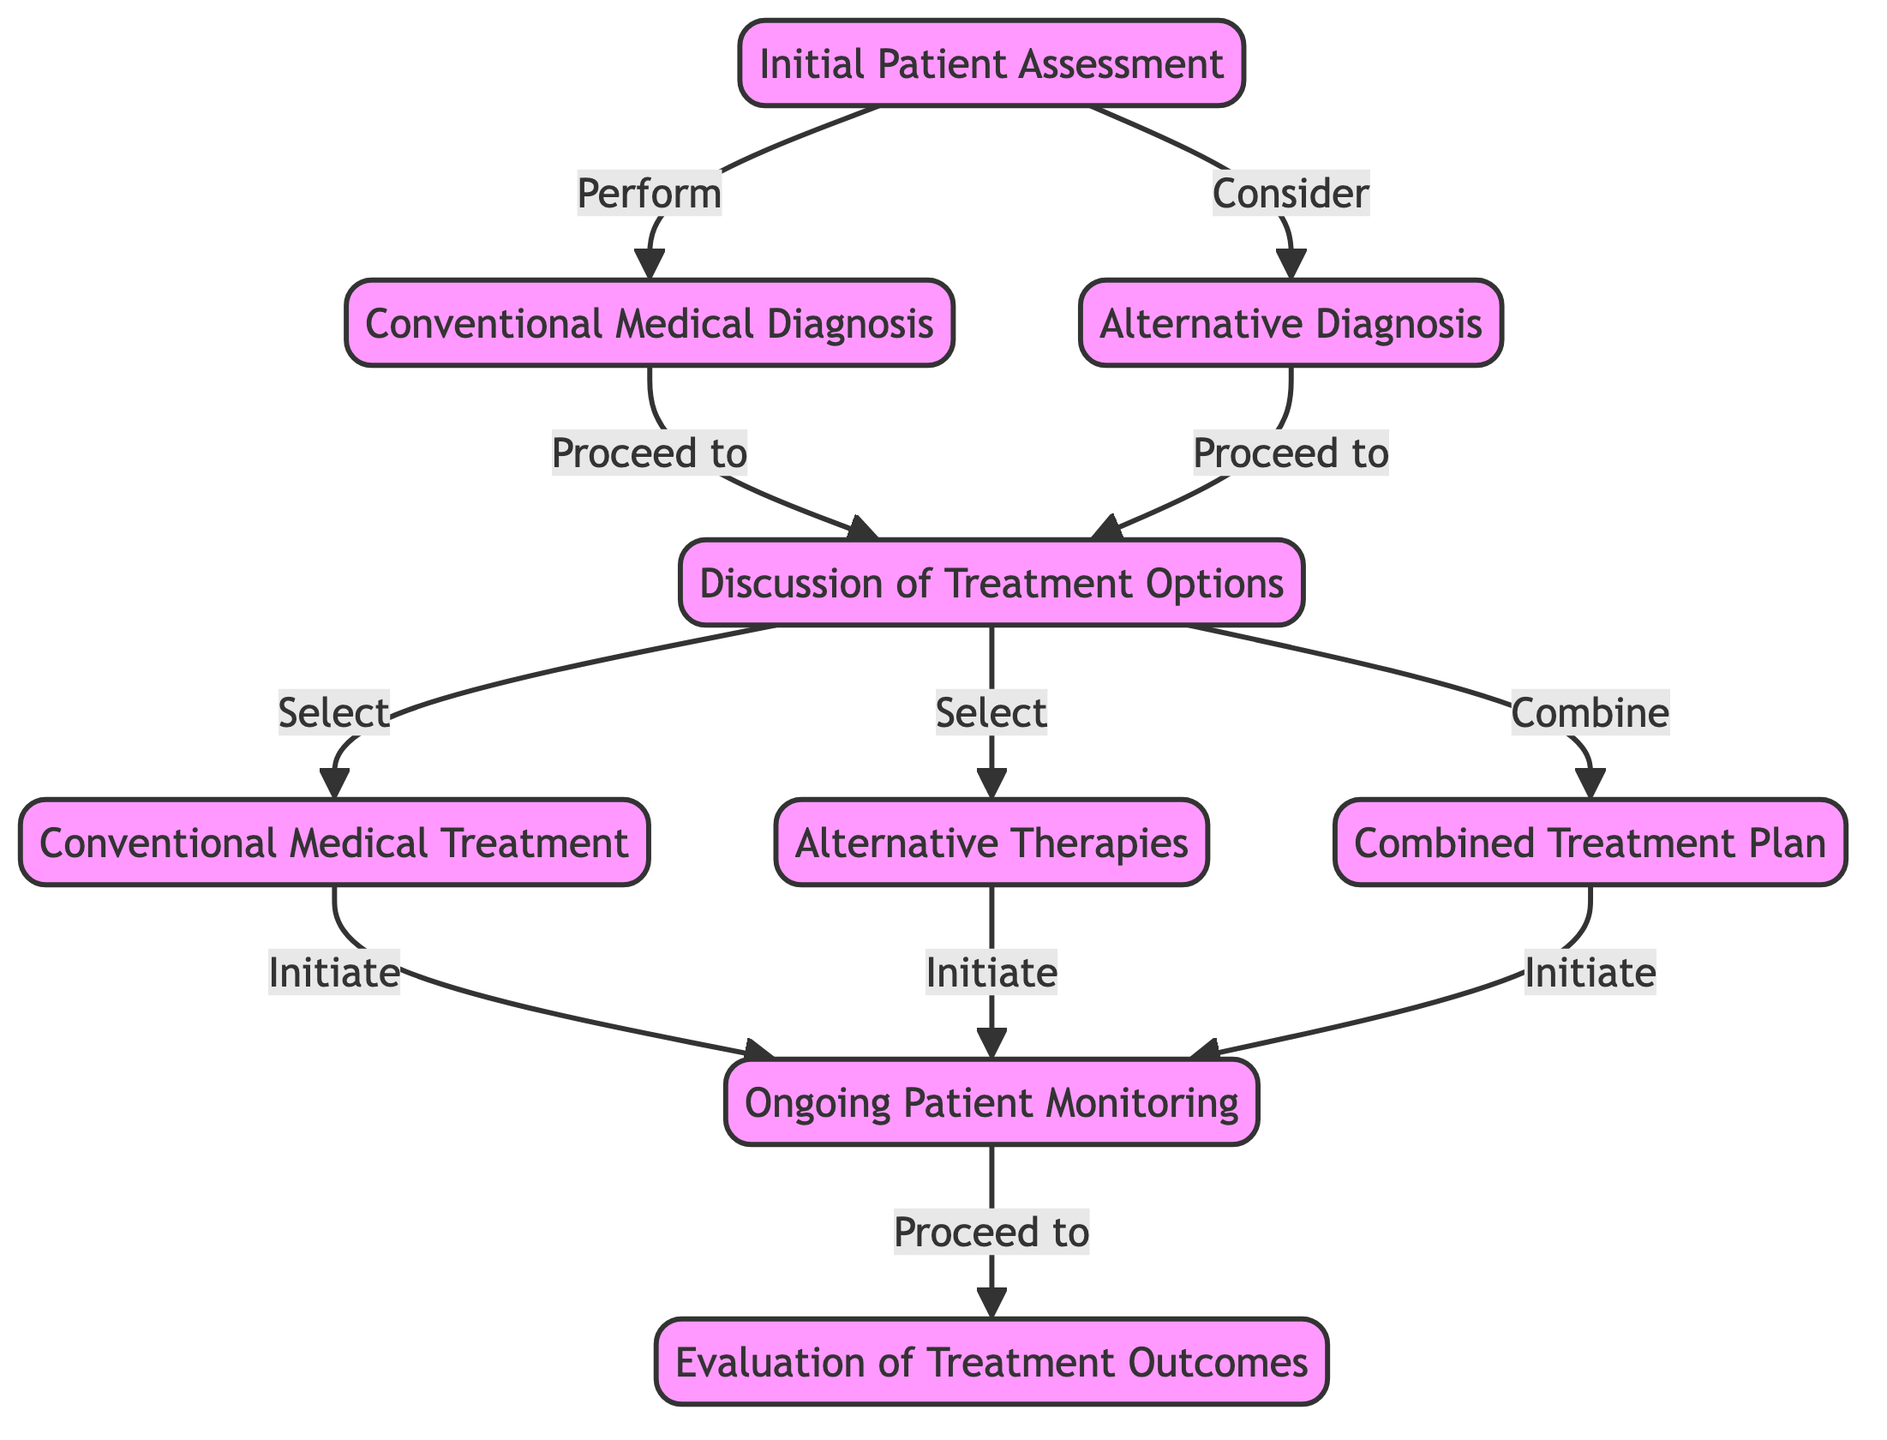What is the first step in the diagram? The diagram indicates that the first step is "Initial Patient Assessment," which is the starting node before any other processes begin.
Answer: Initial Patient Assessment How many treatment options are discussed in the diagram? The diagram shows three treatment options: "Conventional Medical Treatment," "Alternative Therapies," and "Combined Treatment Plan," which indicates a total of three distinct pathways.
Answer: Three What happens after "Ongoing Patient Monitoring"? According to the diagram, after "Ongoing Patient Monitoring," the next step is "Evaluation of Treatment Outcomes," which follows the monitoring stage to assess the effectiveness of the treatment provided.
Answer: Evaluation of Treatment Outcomes Which node does "Combining" link to? The "Combine" link in the diagram leads to the "Combined Treatment Plan," indicating that the selection of combined treatment options is facilitated through this path.
Answer: Combined Treatment Plan What should be considered along with conventional diagnosis? The diagram illustrates that "Alternative Diagnosis" is something that should be considered in conjunction with "Conventional Medical Diagnosis," representing an inclusive approach to patient care.
Answer: Alternative Diagnosis What can lead to "Ongoing Patient Monitoring"? The flowchart indicates that all treatment options, including "Conventional Medical Treatment," "Alternative Therapies," and "Combined Treatment Plan," lead to the "Ongoing Patient Monitoring" stage, emphasizing the importance of monitoring regardless of the treatment pathway chosen.
Answer: Conventional Medical Treatment, Alternative Therapies, Combined Treatment Plan How are the initial assessments connected to diagnoses? The initial assessments are linked to two diagnoses: "Conventional Medical Diagnosis" and "Alternative Diagnosis," showing that both pathways start from the same initial evaluation of the patient.
Answer: Two What type of treatment is initiated after discussing treatment options? After the discussion of treatment options, the flowchart indicates that either "Conventional Medical Treatment," "Alternative Therapies," or "Combined Treatment Plan" is initiated, highlighting multiple possible pathways to proceed.
Answer: Conventional Medical Treatment, Alternative Therapies, Combined Treatment Plan 